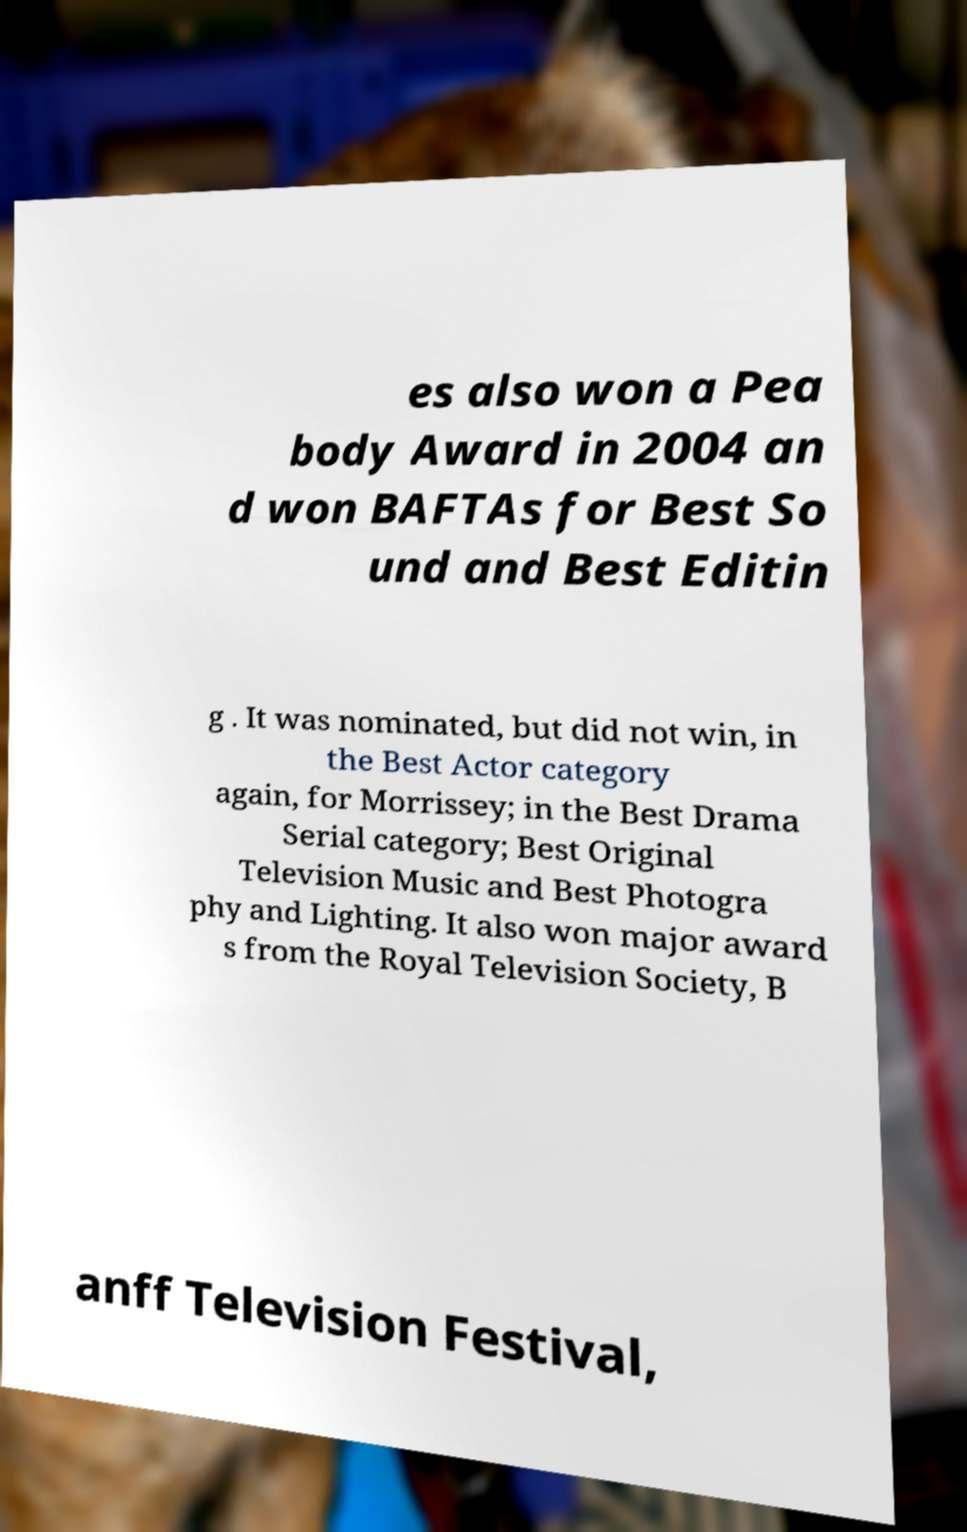Could you extract and type out the text from this image? es also won a Pea body Award in 2004 an d won BAFTAs for Best So und and Best Editin g . It was nominated, but did not win, in the Best Actor category again, for Morrissey; in the Best Drama Serial category; Best Original Television Music and Best Photogra phy and Lighting. It also won major award s from the Royal Television Society, B anff Television Festival, 